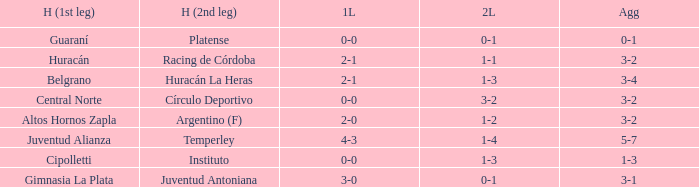What was the score of the 2nd leg when the Belgrano played the first leg at home with a score of 2-1? 1-3. 